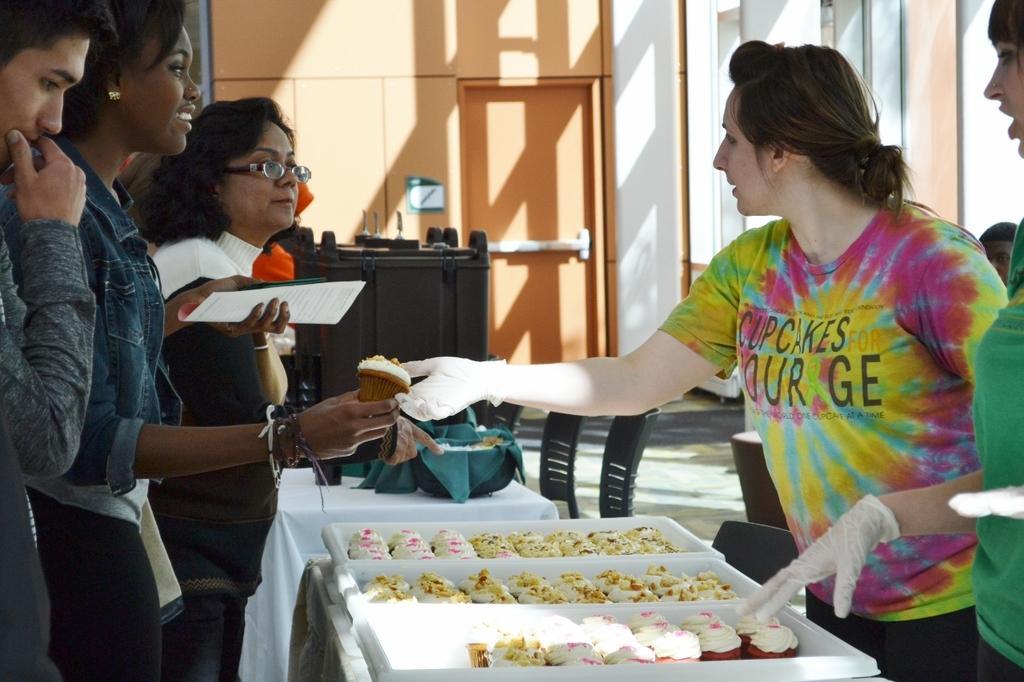How would you summarize this image in a sentence or two? There are two ladies standing in the right corner and there are three other persons standing in front of them and there are few eatables placed on a table in front of them. 